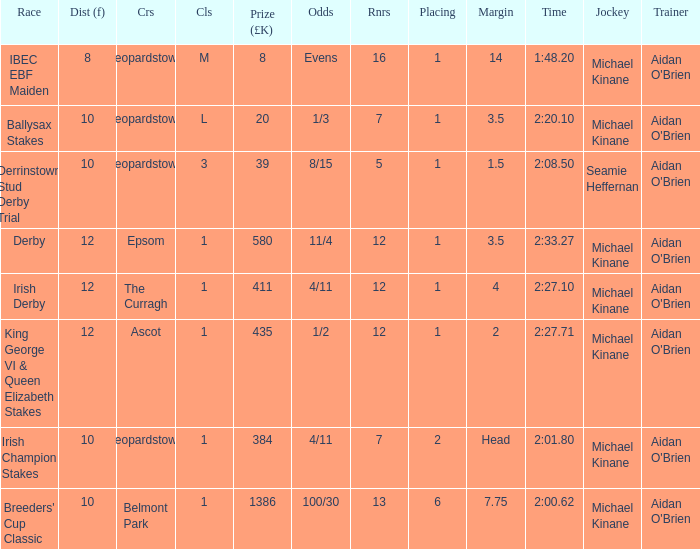Which Race has a Runners of 7 and Odds of 1/3? Ballysax Stakes. 